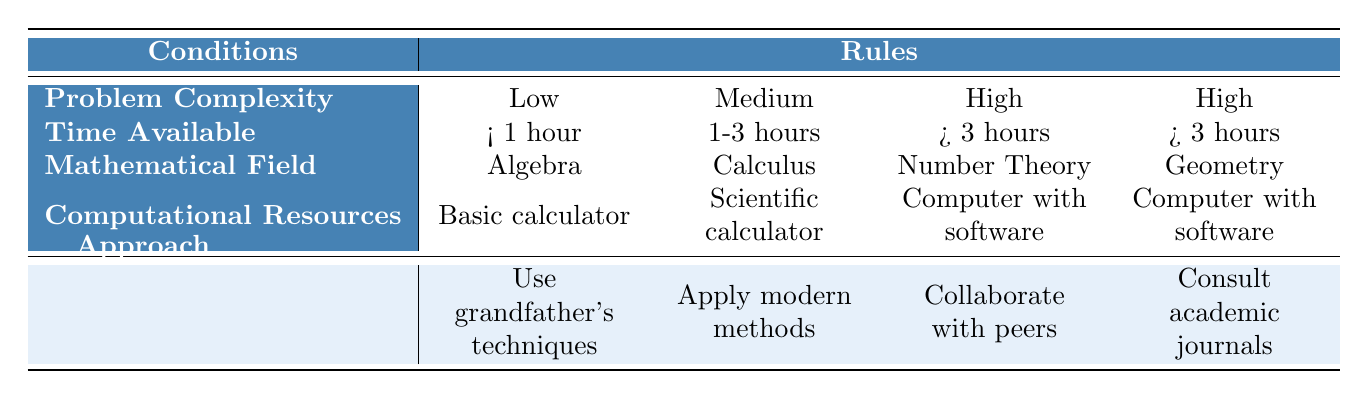What approach should be taken for a low complexity algebra problem with less than 1 hour available? The table indicates that for a Low complexity, Less than 1 hour problem in Algebra, the recommended action is to "Use grandfather's problem-solving techniques".
Answer: Use grandfather's problem-solving techniques Which mathematical field would you consult academic journals for when you have more than 3 hours available? The table shows that for a High complexity, More than 3 hours problem in Geometry, the recommended action is to "Consult academic journals".
Answer: Geometry Is it required to use a computer with software for all high complexity problems? The table lists two high complexity problems: one in Number Theory and one in Geometry; both require a Computer with software for their respective actions. Hence, yes, for these specific problems it is required, but it does not apply to all high complexity problems in general since other mathematical fields may not be included.
Answer: No What is the action recommended for a medium complexity number theory problem if you have a scientific calculator and 1-3 hours available? The table states that for a Medium complexity problem in Number Theory with a Scientific calculator and 1-3 hours available, the action is to "Attempt multiple solution paths".
Answer: Attempt multiple solution paths For a high complexity problem in Number Theory with more than 3 hours available, what action should be taken? According to the table, for a High complexity, More than 3 hours problem in Number Theory, the action is to "Collaborate with peers".
Answer: Collaborate with peers If the time available is less than 1 hour and the computational resources are only a basic calculator, which mathematical field can still allow the use of grandfather's problem-solving techniques? The table specifies that if the Problem is Low complexity (using Algebra) with less than 1 hour available and a Basic calculator, then you should "Use grandfather's problem-solving techniques". This means the mathematical field must be Algebra.
Answer: Algebra What is the difference in recommended approaches for a medium complexity problem in calculus versus a high complexity problem in geometry? The table indicates that for Medium complexity and 1-3 hours in Calculus, the action is to "Apply modern computational methods". In contrast, for High complexity and more than 3 hours in Geometry, the action is to "Consult academic journals". The difference in approaches highlights the need for modern methods in less complex scenarios versus academic consultation for more complex problems.
Answer: Apply modern methods vs. Consult academic journals Can you use a scientific calculator to solve low complexity problems in Number Theory? The table does not list any recommended action for Low complexity problems in Number Theory with a Scientific calculator. The only specific recommendation for a Low complexity problem involves Algebra, which means the answer is no for a direct scientific calculator application in Number Theory.
Answer: No 